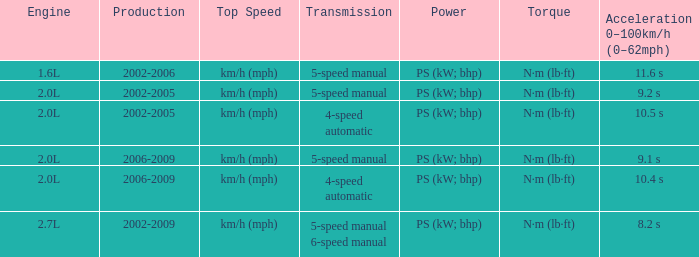What is the acceleration 0-100km/h that was produced in 2002-2006? 11.6 s. 